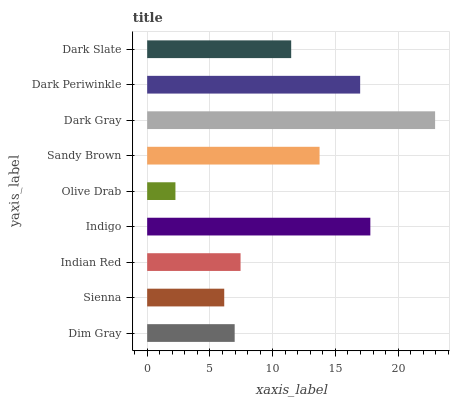Is Olive Drab the minimum?
Answer yes or no. Yes. Is Dark Gray the maximum?
Answer yes or no. Yes. Is Sienna the minimum?
Answer yes or no. No. Is Sienna the maximum?
Answer yes or no. No. Is Dim Gray greater than Sienna?
Answer yes or no. Yes. Is Sienna less than Dim Gray?
Answer yes or no. Yes. Is Sienna greater than Dim Gray?
Answer yes or no. No. Is Dim Gray less than Sienna?
Answer yes or no. No. Is Dark Slate the high median?
Answer yes or no. Yes. Is Dark Slate the low median?
Answer yes or no. Yes. Is Indigo the high median?
Answer yes or no. No. Is Sandy Brown the low median?
Answer yes or no. No. 